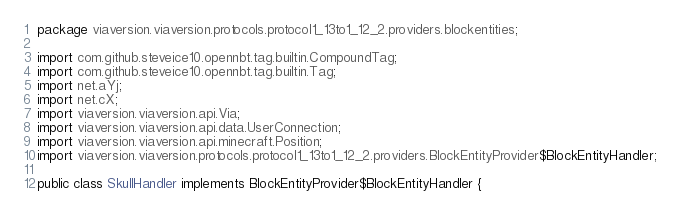<code> <loc_0><loc_0><loc_500><loc_500><_Java_>package viaversion.viaversion.protocols.protocol1_13to1_12_2.providers.blockentities;

import com.github.steveice10.opennbt.tag.builtin.CompoundTag;
import com.github.steveice10.opennbt.tag.builtin.Tag;
import net.aYj;
import net.cX;
import viaversion.viaversion.api.Via;
import viaversion.viaversion.api.data.UserConnection;
import viaversion.viaversion.api.minecraft.Position;
import viaversion.viaversion.protocols.protocol1_13to1_12_2.providers.BlockEntityProvider$BlockEntityHandler;

public class SkullHandler implements BlockEntityProvider$BlockEntityHandler {</code> 